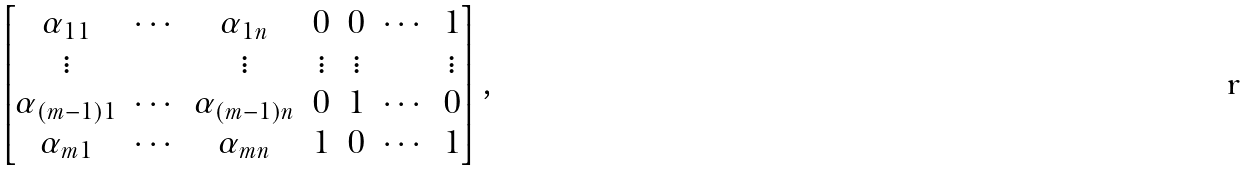<formula> <loc_0><loc_0><loc_500><loc_500>\begin{bmatrix} \alpha _ { 1 1 } & \cdots & \alpha _ { 1 n } & 0 & 0 & \cdots & 1 \\ \vdots & & \vdots & \vdots & \vdots & & \vdots \\ \alpha _ { ( m - 1 ) 1 } & \cdots & \alpha _ { ( m - 1 ) n } & 0 & 1 & \cdots & 0 \\ \alpha _ { m 1 } & \cdots & \alpha _ { m n } & 1 & 0 & \cdots & 1 \\ \end{bmatrix} ,</formula> 